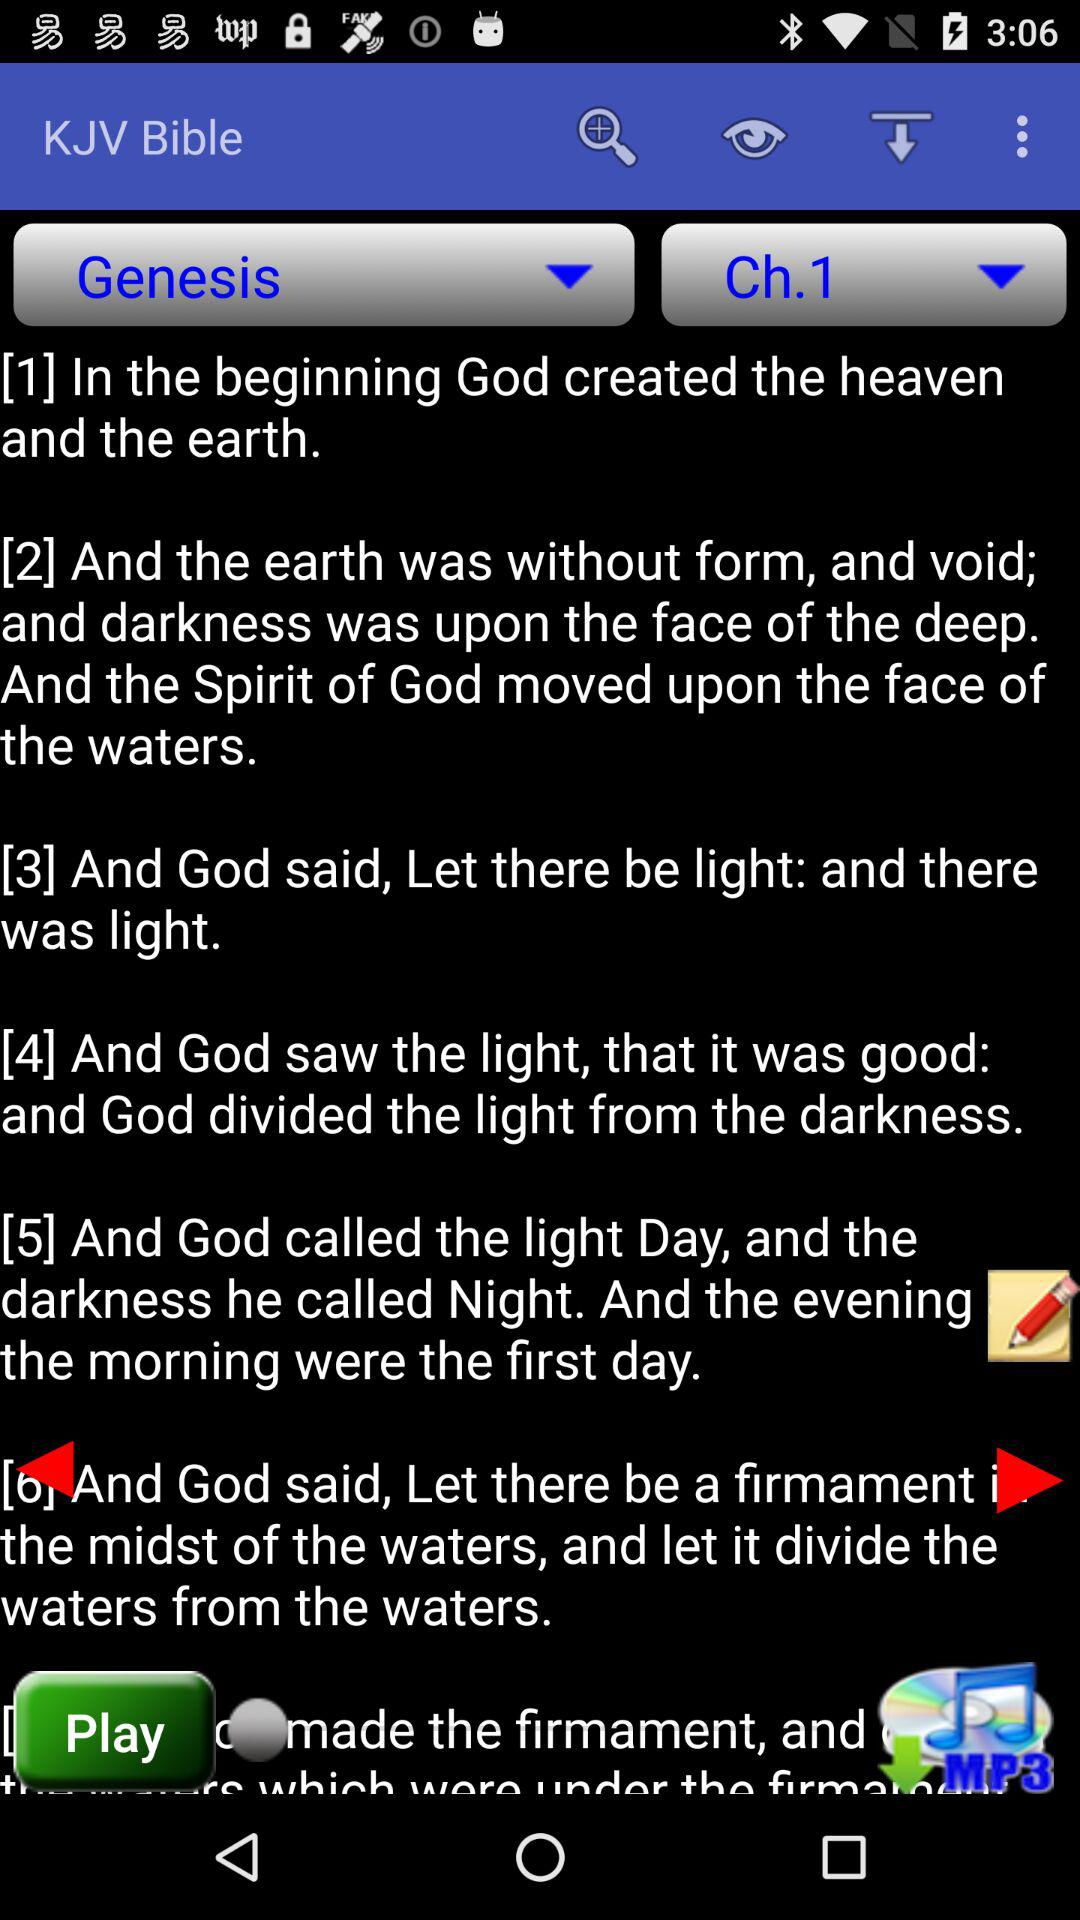What is the application name? The application name is "KJV Bible". 